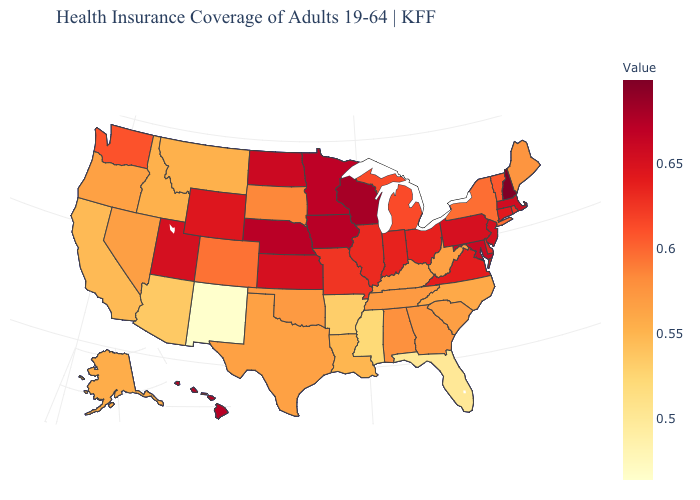Does New Hampshire have the highest value in the USA?
Write a very short answer. Yes. Among the states that border Montana , which have the lowest value?
Answer briefly. Idaho. Among the states that border Oregon , which have the lowest value?
Answer briefly. California. Which states hav the highest value in the South?
Give a very brief answer. Maryland. Does Wisconsin have the highest value in the MidWest?
Concise answer only. Yes. Does Florida have the lowest value in the USA?
Answer briefly. No. Which states have the highest value in the USA?
Be succinct. New Hampshire. 